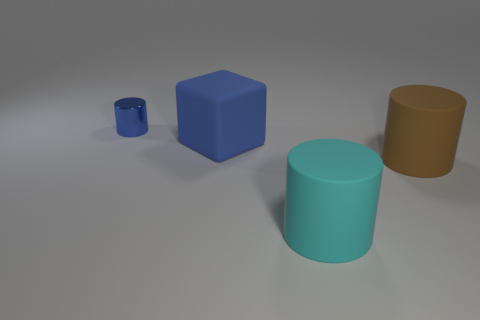Add 4 small green metal cubes. How many objects exist? 8 Subtract all cubes. How many objects are left? 3 Add 2 brown things. How many brown things are left? 3 Add 4 small cylinders. How many small cylinders exist? 5 Subtract 0 gray cylinders. How many objects are left? 4 Subtract all cyan shiny balls. Subtract all big brown cylinders. How many objects are left? 3 